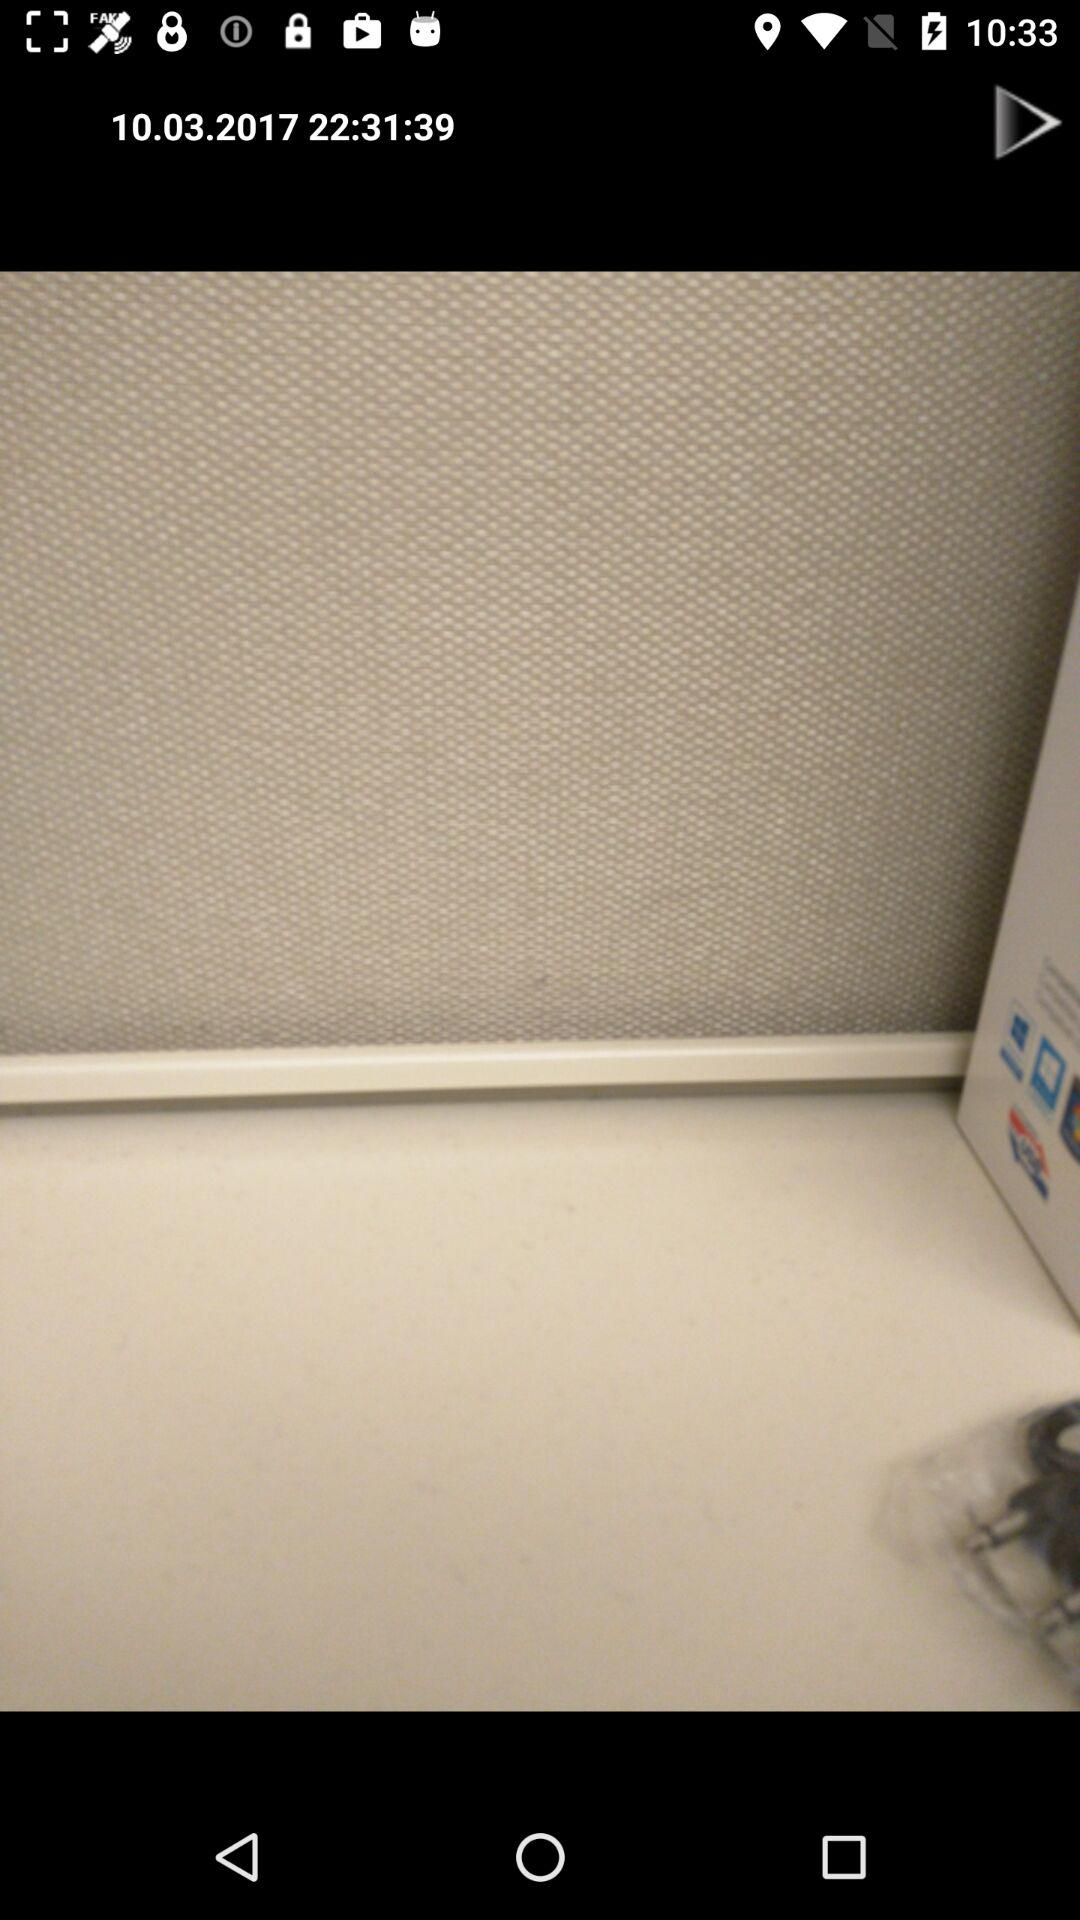Who took this photo?
When the provided information is insufficient, respond with <no answer>. <no answer> 